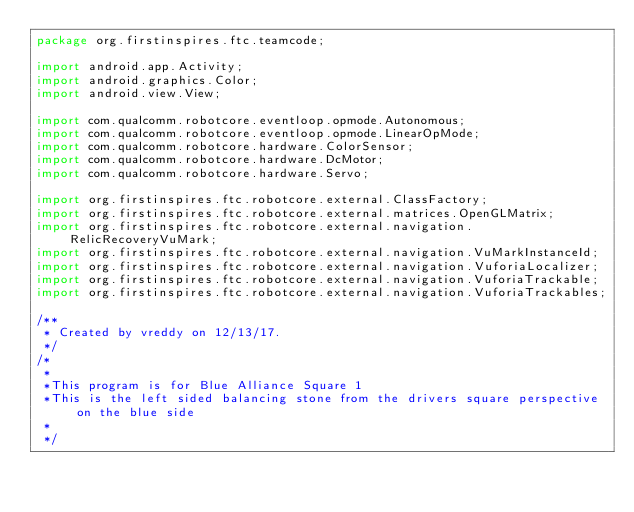Convert code to text. <code><loc_0><loc_0><loc_500><loc_500><_Java_>package org.firstinspires.ftc.teamcode;

import android.app.Activity;
import android.graphics.Color;
import android.view.View;

import com.qualcomm.robotcore.eventloop.opmode.Autonomous;
import com.qualcomm.robotcore.eventloop.opmode.LinearOpMode;
import com.qualcomm.robotcore.hardware.ColorSensor;
import com.qualcomm.robotcore.hardware.DcMotor;
import com.qualcomm.robotcore.hardware.Servo;

import org.firstinspires.ftc.robotcore.external.ClassFactory;
import org.firstinspires.ftc.robotcore.external.matrices.OpenGLMatrix;
import org.firstinspires.ftc.robotcore.external.navigation.RelicRecoveryVuMark;
import org.firstinspires.ftc.robotcore.external.navigation.VuMarkInstanceId;
import org.firstinspires.ftc.robotcore.external.navigation.VuforiaLocalizer;
import org.firstinspires.ftc.robotcore.external.navigation.VuforiaTrackable;
import org.firstinspires.ftc.robotcore.external.navigation.VuforiaTrackables;

/**
 * Created by vreddy on 12/13/17.
 */
/*
 *
 *This program is for Blue Alliance Square 1
 *This is the left sided balancing stone from the drivers square perspective on the blue side
 *
 */</code> 